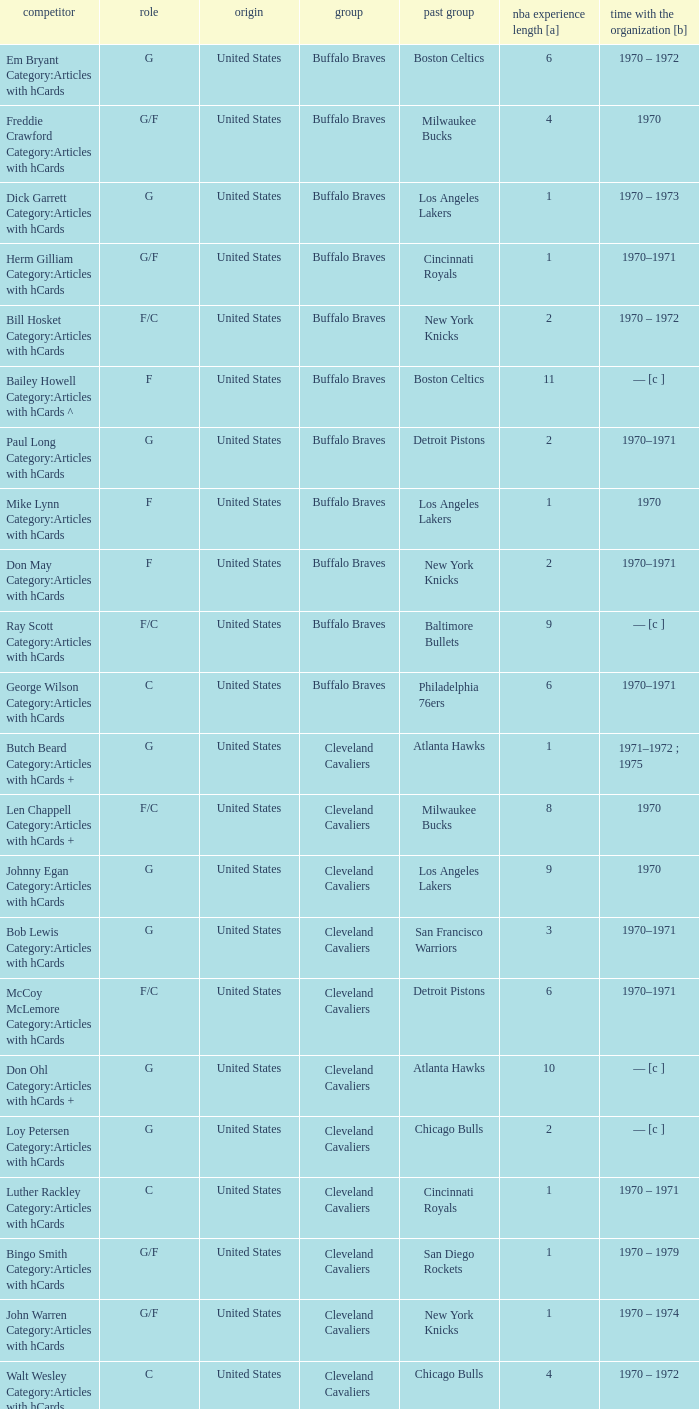Who is the player with 7 years of NBA experience? Larry Siegfried Category:Articles with hCards. 